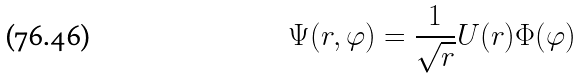<formula> <loc_0><loc_0><loc_500><loc_500>\Psi ( r , \varphi ) = \frac { 1 } { \sqrt { r } } U ( r ) \Phi ( \varphi )</formula> 